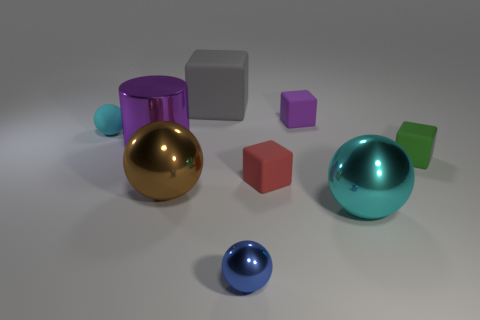What time of day would you say this scene resembles based on lighting? Based on the lighting, which has a diffuse quality with soft shadows, the scene could resemble a time in the morning or late afternoon, when the sun is not at its peak and the light is not as harsh as during midday. 